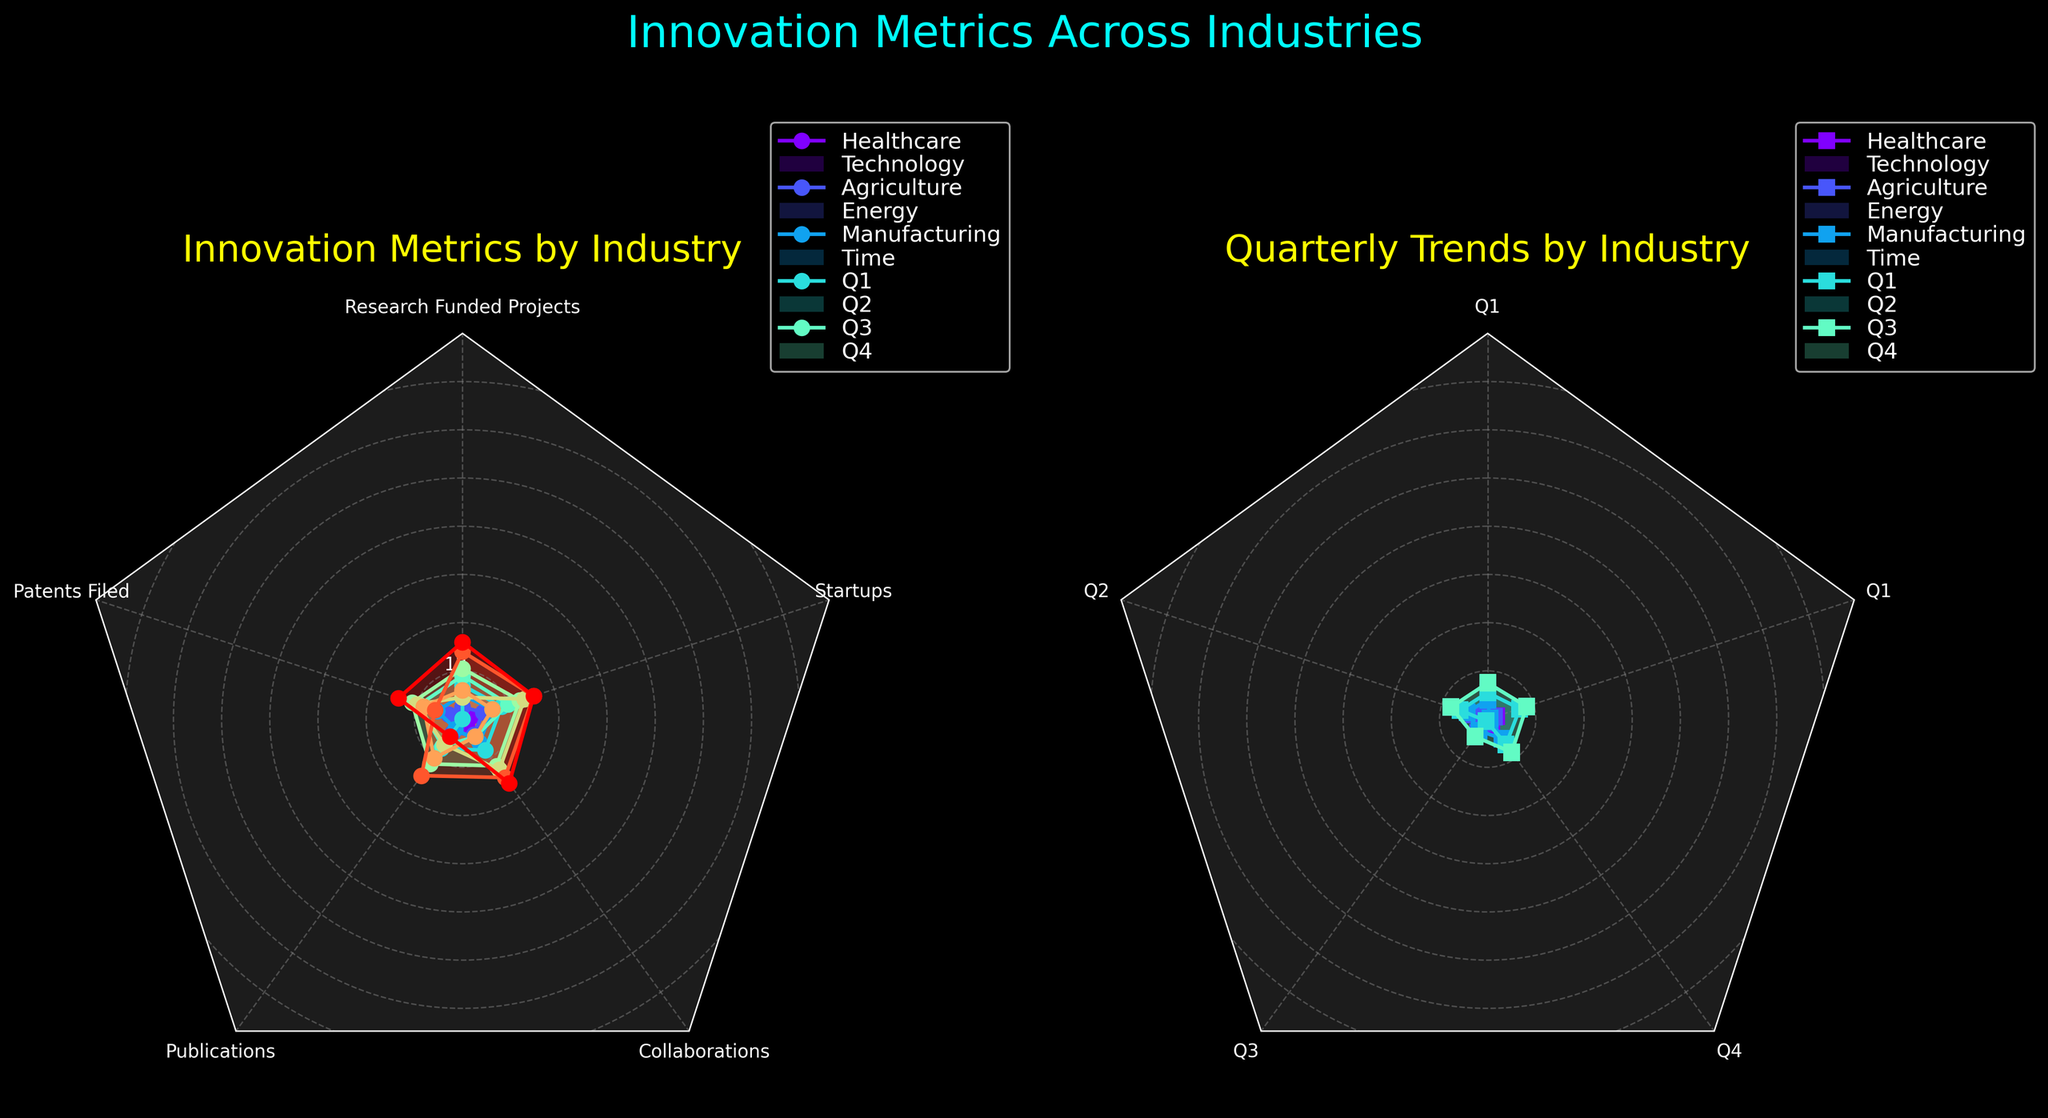How many industries are displayed in the figure? There are individual lines represented by different colors in each subplot, each corresponding to an industry. Counting these lines gives the number of industries.
Answer: 5 What are the titles of the subplots? The figure has two subplot titles. The first subplot is titled "Innovation Metrics by Industry", and the second subplot is titled "Quarterly Trends by Industry".
Answer: "Innovation Metrics by Industry" and "Quarterly Trends by Industry" Which industry has the highest number of funded research projects in the first subplot? In the first subplot ("Innovation Metrics by Industry"), the radar chart shows different innovation metrics for each industry. The healthcare industry peaks at the highest value for the research funded projects metric.
Answer: Healthcare How does the number of patents filed in the Technology industry compare to that in the Energy industry in the first subplot? In the first subplot, comparing the value on the 'Patents Filed' axis shows that the Technology industry has 100 patents filed, while the Energy industry has 80.
Answer: Technology has more patents filed than Energy What is the average value for collaborations across all industries in the first subplot? Add the values for collaborations across all industries: 35 (Healthcare) + 45 (Technology) + 20 (Agriculture) + 30 (Energy) + 15 (Manufacturing) = 145. Then, divide by the number of industries (5). 145 / 5 = 29.
Answer: 29 Which industry shows a consistent increase in values across all quarters in the second subplot? In the second subplot ("Quarterly Trends by Industry"), tracking the values from Q1 to Q4 shows that the Healthcare industry has consistently increasing values across all quarters (Q1: 15, Q2: 20, Q3: 22, Q4: 23).
Answer: Healthcare Comparing the startups metrics, which industry has the least number of startups in the first subplot? In the first subplot, the values for the 'Startups' metrics are 25 (Healthcare), 15 (Technology), 10 (Agriculture), 18 (Energy), and 12 (Manufacturing). The Agriculture industry has the least number of startups.
Answer: Agriculture What is the range of publication values in the first subplot? The highest value for publications is in the Healthcare industry (150), and the lowest is in the Manufacturing industry (65). The range is 150 - 65 = 85.
Answer: 85 Between the Technology and Manufacturing industries, which one has higher values for startups in the fourth quarter in the second subplot? In the second subplot, comparing the value for 'Q4' shows that Technology has a value of 22, while Manufacturing has 11. Therefore, Technology has higher values for startups in the fourth quarter.
Answer: Technology 